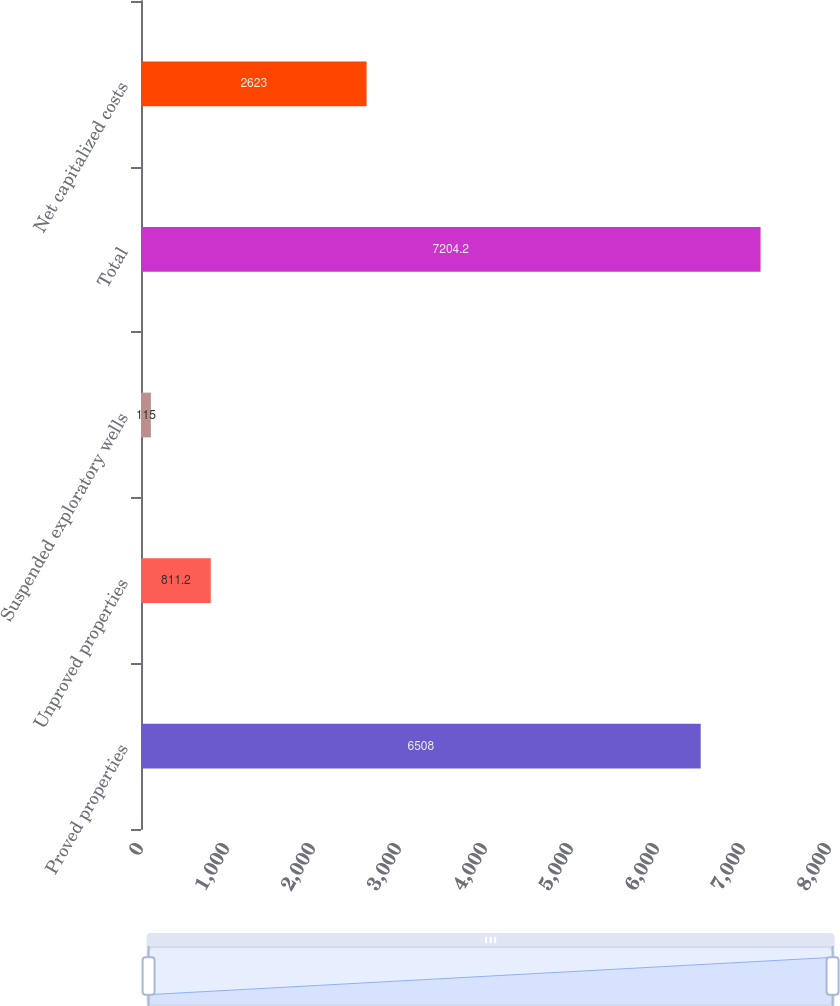Convert chart. <chart><loc_0><loc_0><loc_500><loc_500><bar_chart><fcel>Proved properties<fcel>Unproved properties<fcel>Suspended exploratory wells<fcel>Total<fcel>Net capitalized costs<nl><fcel>6508<fcel>811.2<fcel>115<fcel>7204.2<fcel>2623<nl></chart> 